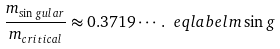Convert formula to latex. <formula><loc_0><loc_0><loc_500><loc_500>\frac { m _ { \sin g u l a r } } { m _ { c r i t i c a l } } \approx 0 . 3 7 1 9 \cdots \, . \ e q l a b e l { m \sin g }</formula> 